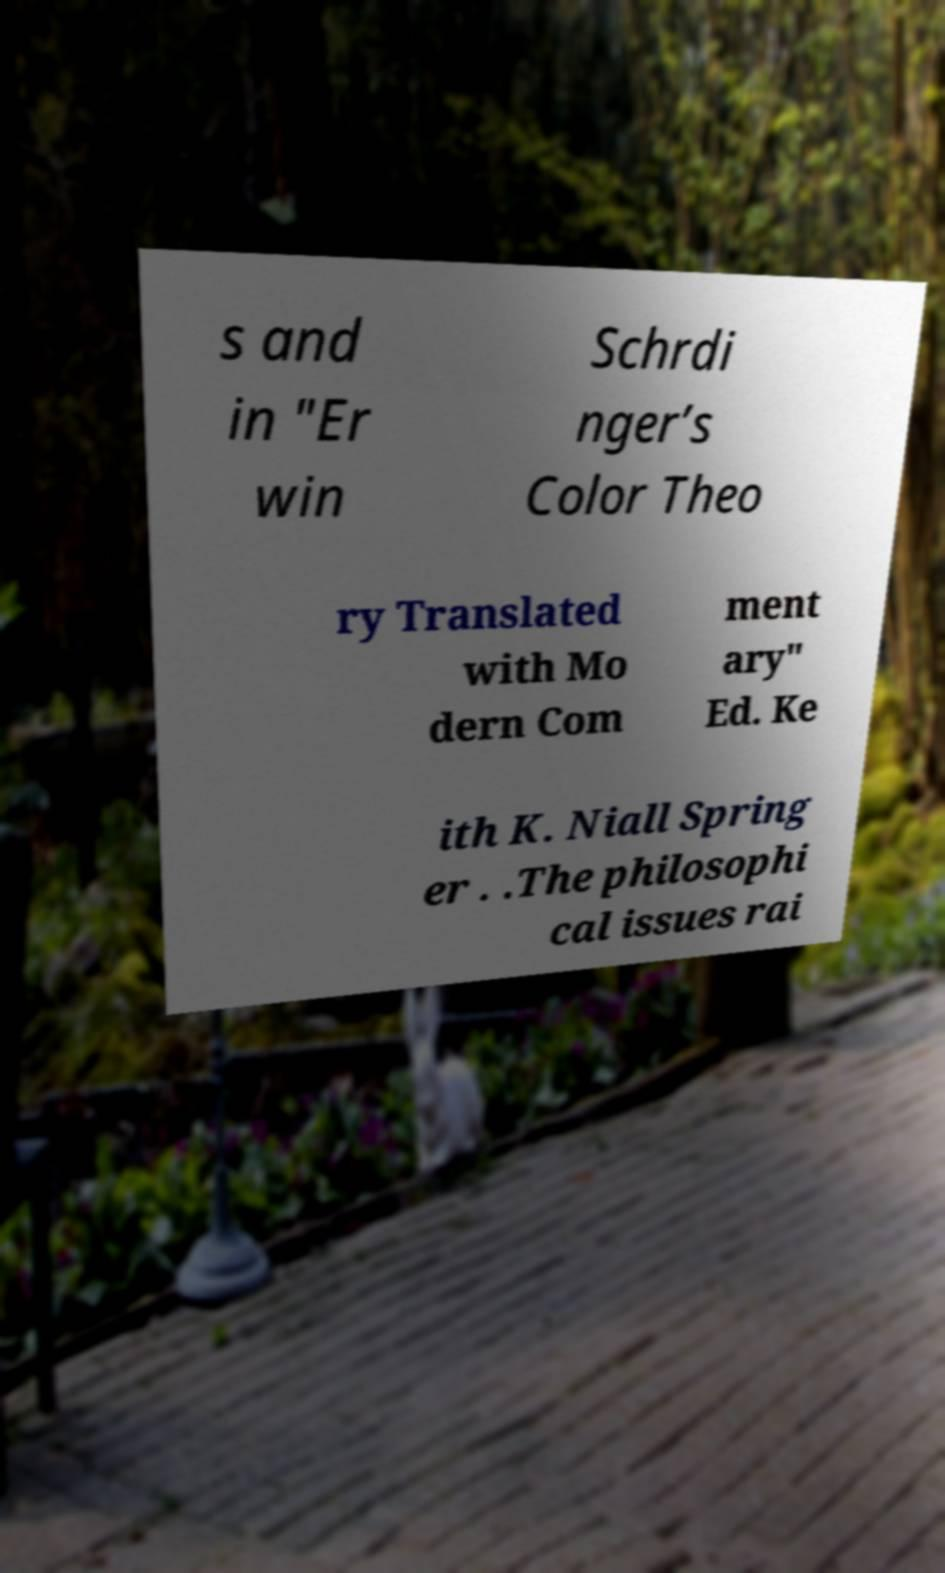Can you accurately transcribe the text from the provided image for me? s and in "Er win Schrdi nger’s Color Theo ry Translated with Mo dern Com ment ary" Ed. Ke ith K. Niall Spring er . .The philosophi cal issues rai 